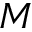Convert formula to latex. <formula><loc_0><loc_0><loc_500><loc_500>M</formula> 